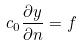Convert formula to latex. <formula><loc_0><loc_0><loc_500><loc_500>c _ { 0 } \frac { \partial y } { \partial n } = f</formula> 